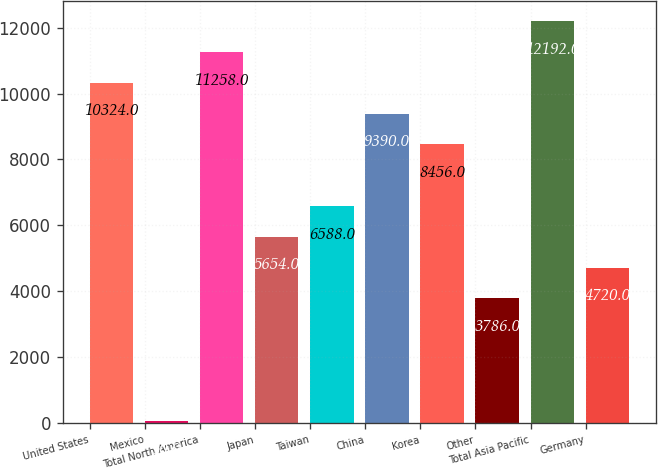<chart> <loc_0><loc_0><loc_500><loc_500><bar_chart><fcel>United States<fcel>Mexico<fcel>Total North America<fcel>Japan<fcel>Taiwan<fcel>China<fcel>Korea<fcel>Other<fcel>Total Asia Pacific<fcel>Germany<nl><fcel>10324<fcel>50<fcel>11258<fcel>5654<fcel>6588<fcel>9390<fcel>8456<fcel>3786<fcel>12192<fcel>4720<nl></chart> 